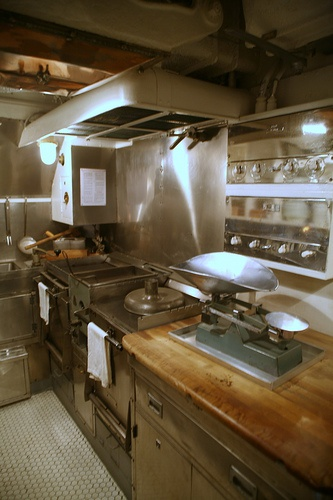Describe the objects in this image and their specific colors. I can see oven in black, gray, and darkgray tones, wine glass in black, darkgray, gray, and lightgray tones, wine glass in black, darkgray, and gray tones, wine glass in black, gray, and darkgray tones, and wine glass in black, gray, and darkgray tones in this image. 